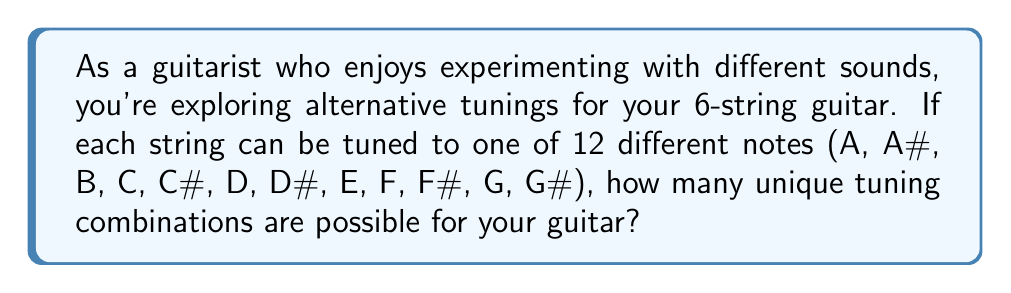What is the answer to this math problem? To solve this problem, we need to use the multiplication principle of counting. Here's a step-by-step explanation:

1. We have 6 strings on the guitar, and each string can be tuned to any of the 12 notes.

2. For each string, we have 12 choices, and these choices are independent of each other. This means we can use the multiplication principle.

3. The total number of possible tuning combinations is:

   $$ 12 \times 12 \times 12 \times 12 \times 12 \times 12 $$

4. This can be written as an exponent:

   $$ 12^6 $$

5. To calculate this:
   
   $$ 12^6 = 12 \times 12 \times 12 \times 12 \times 12 \times 12 = 2,985,984 $$

Therefore, there are 2,985,984 possible unique tuning combinations for a 6-string guitar when each string can be tuned to any of the 12 notes.

Note: In practice, not all of these combinations would be musically useful or common, but mathematically, they are all possible.
Answer: $$ 12^6 = 2,985,984 $$ possible tuning combinations 